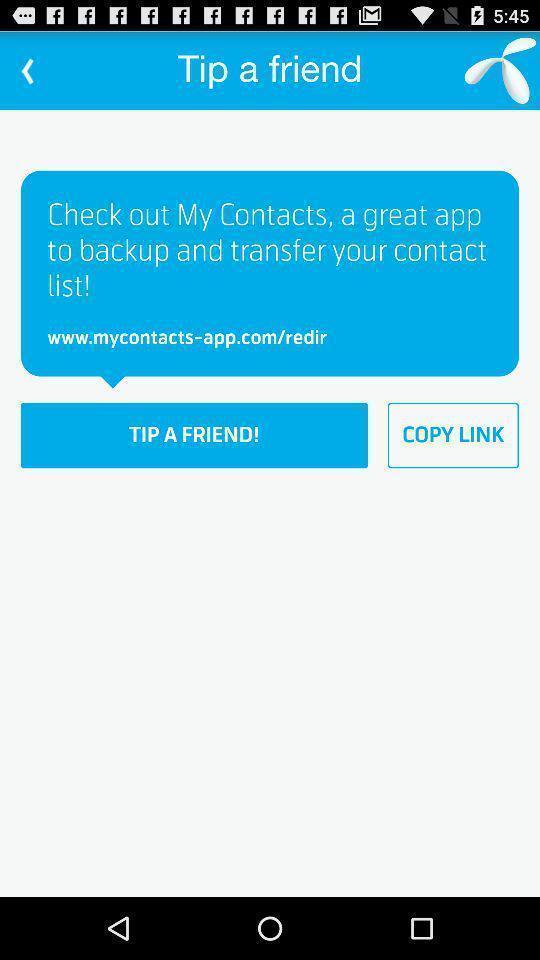Summarize the main components in this picture. Page showing information about contact app. 